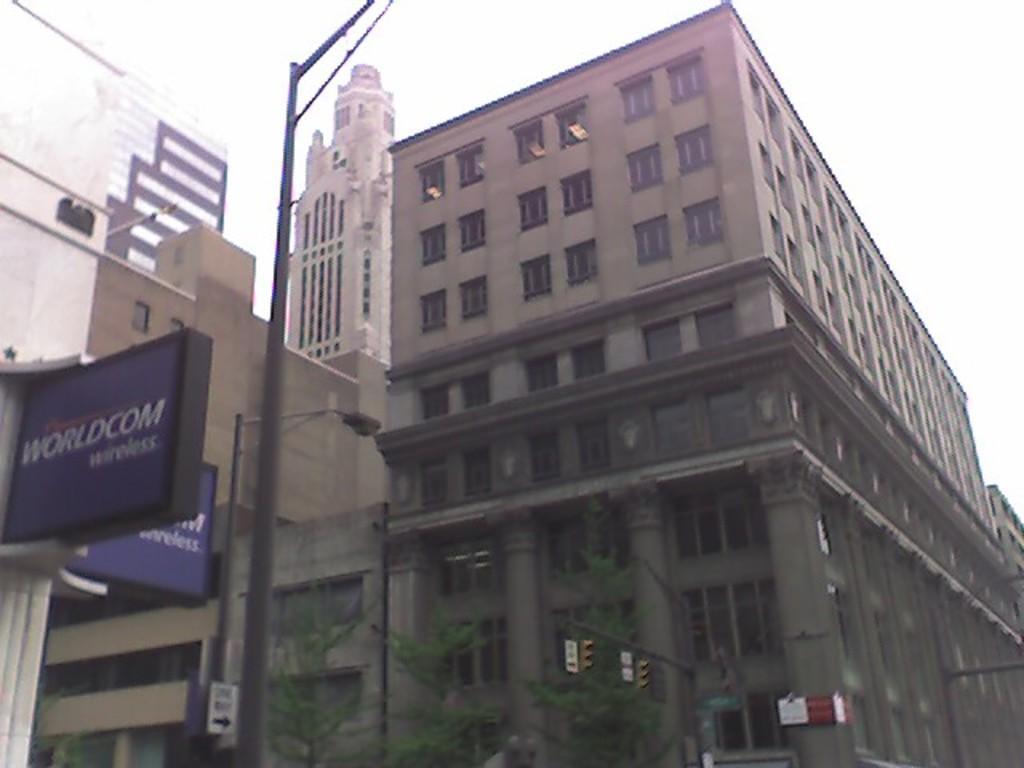Could you give a brief overview of what you see in this image? As we can see in the image there are buildings, street lamp, banners, plants and sky. 